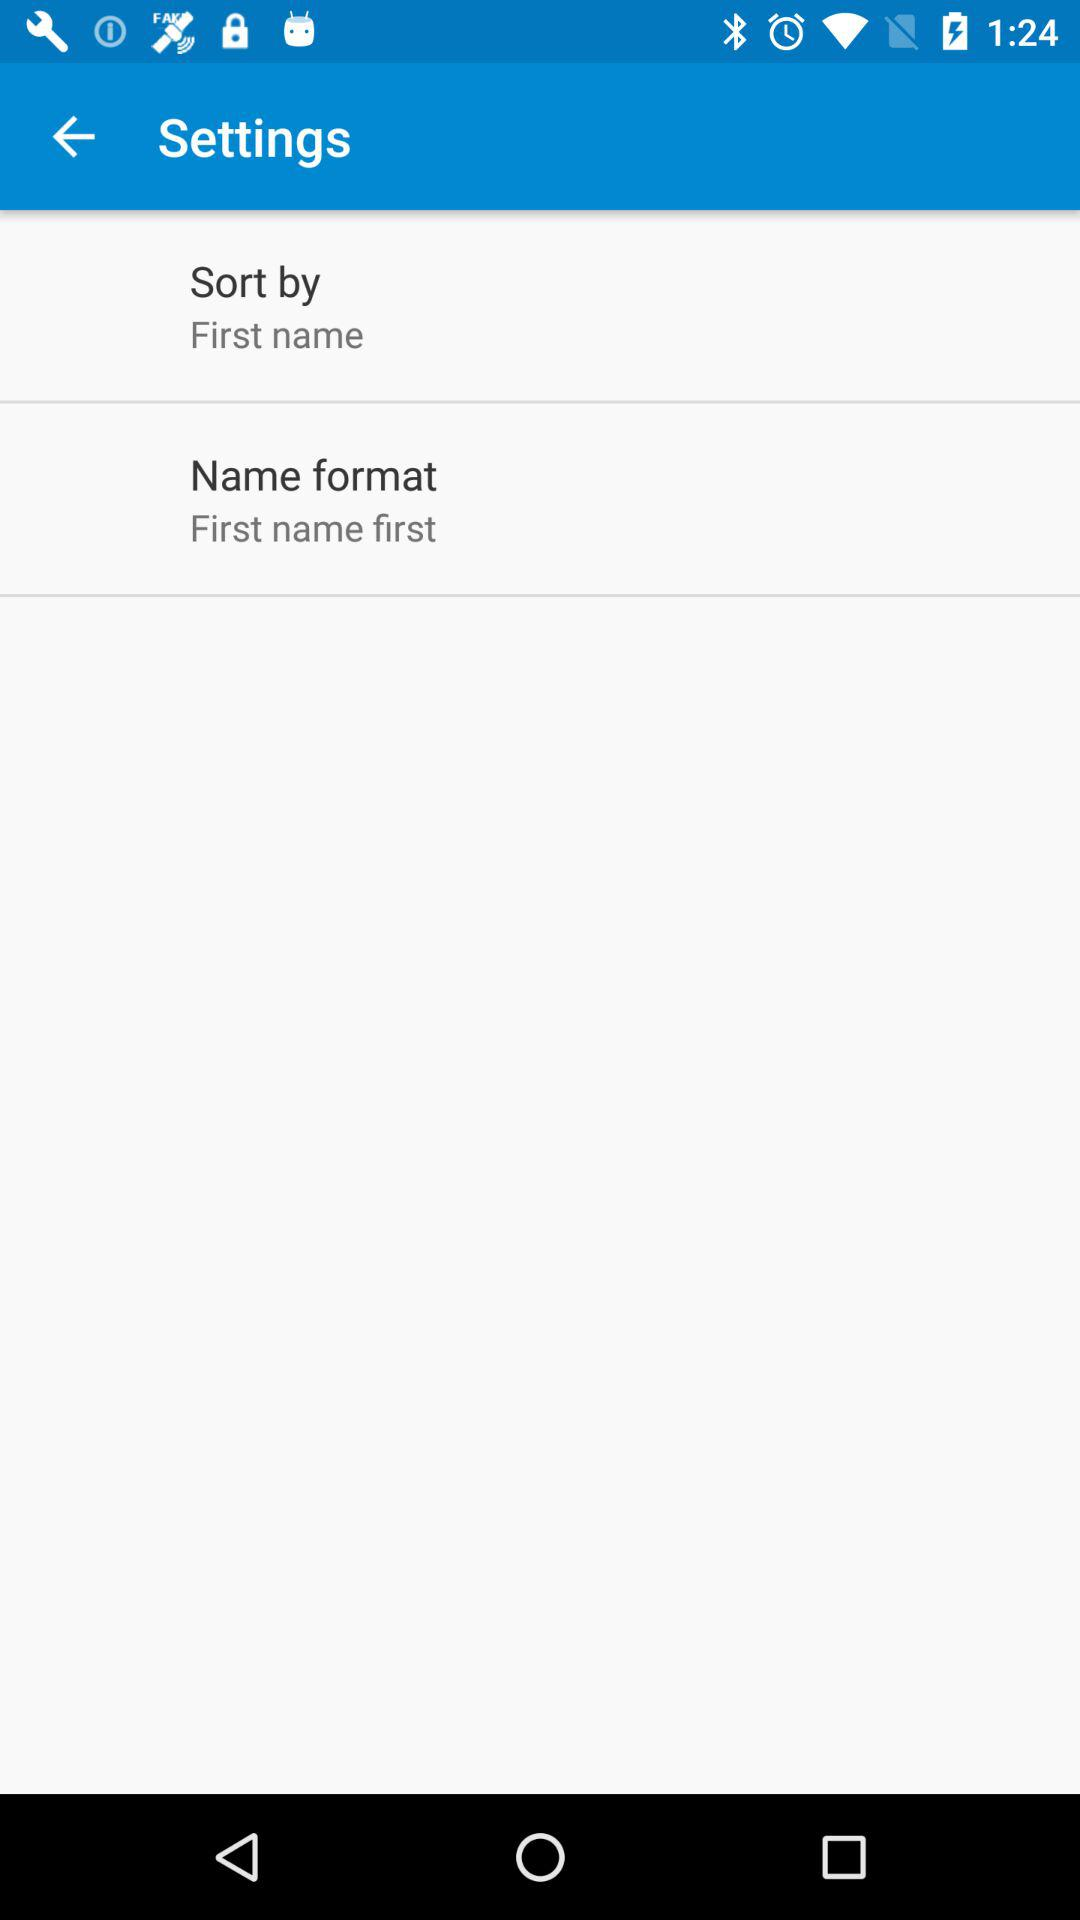What is the setting for "Sort by"? The setting for "Sort by" is "First name". 